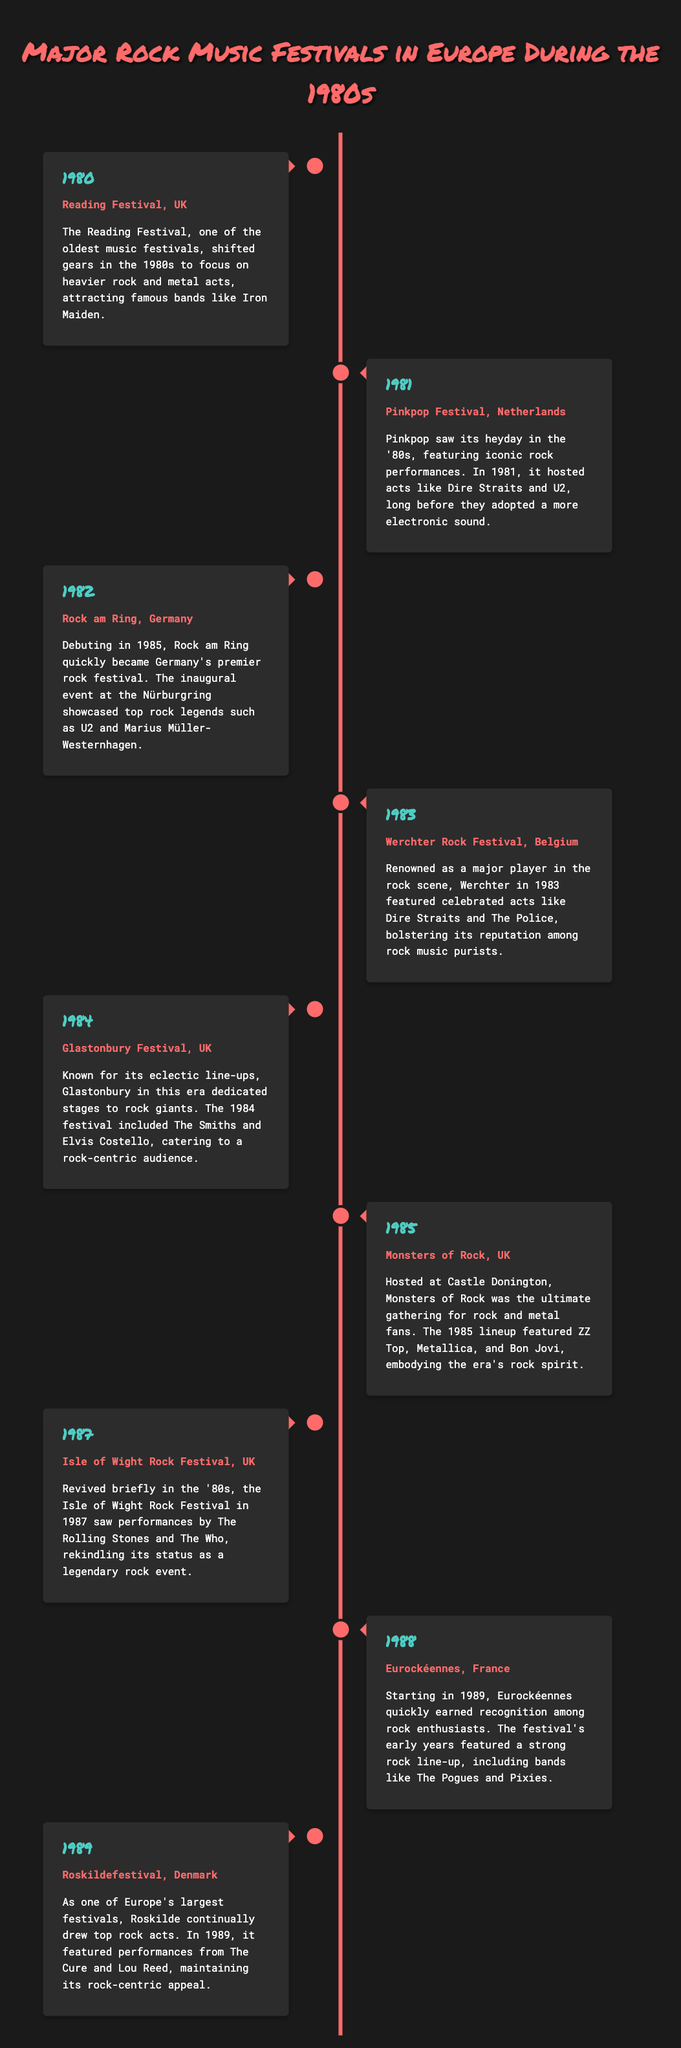what year did the Reading Festival take place? The Reading Festival occurred in 1980, as noted in the timeline.
Answer: 1980 which festival featured Dire Straits and U2 in 1981? The Pinkpop Festival hosted these acts in 1981.
Answer: Pinkpop Festival what genre predominantly characterized the 1985 Monsters of Rock? The lineup included rock and metal acts, indicating these genres characterized the festival.
Answer: Rock and metal how many festivals are mentioned in the document? There are eight festivals listed throughout the timeline, spanning the 1980s.
Answer: Eight which festival is mentioned as being revived in 1987? The Isle of Wight Rock Festival is noted to have been revived in that year.
Answer: Isle of Wight Rock Festival which festival took place in Germany in 1982? The document states that Rock am Ring was the significant festival in Germany during that year.
Answer: Rock am Ring what band performed at the Werchter Rock Festival in 1983? Dire Straits is listed among the celebrated acts for that festival.
Answer: Dire Straits in which country did the Eurockéennes festival start? The Eurockéennes festival started in France, as indicated in the document.
Answer: France 